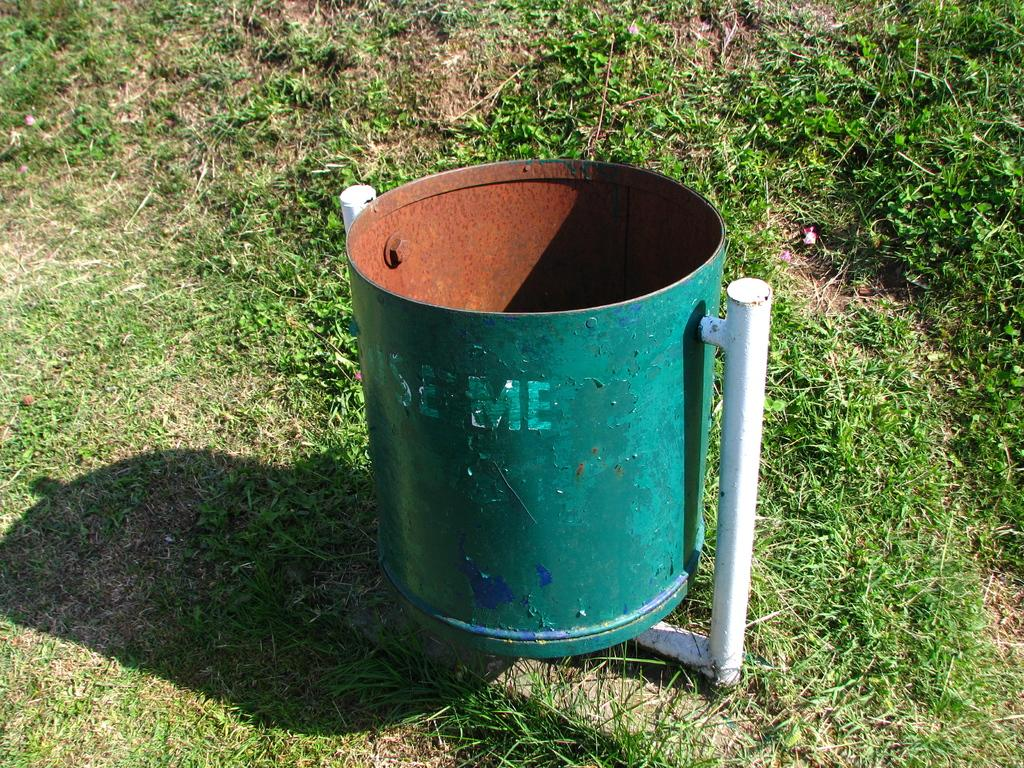What is the main object in the center of the image? There is a garbage tin in the center of the image. What type of environment can be seen in the image? There is grassland visible in the image. What type of roof can be seen on the garbage tin in the image? There is no roof on the garbage tin in the image, as it is an open container. 